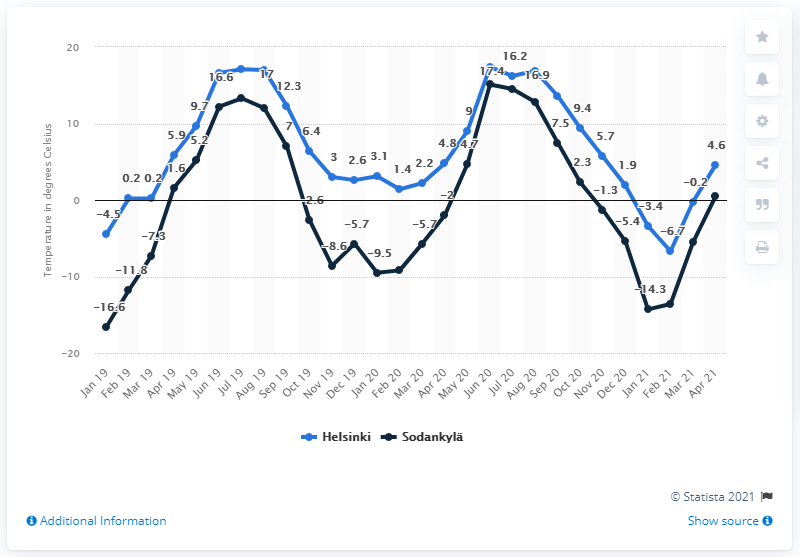Indicate a few pertinent items in this graphic. In April 2021, the city of Sodankylä in Northern Finland had a monthly average temperature of 0.5 degrees Celsius, making it the ideal location for those seeking a chilly and refreshing getaway. 